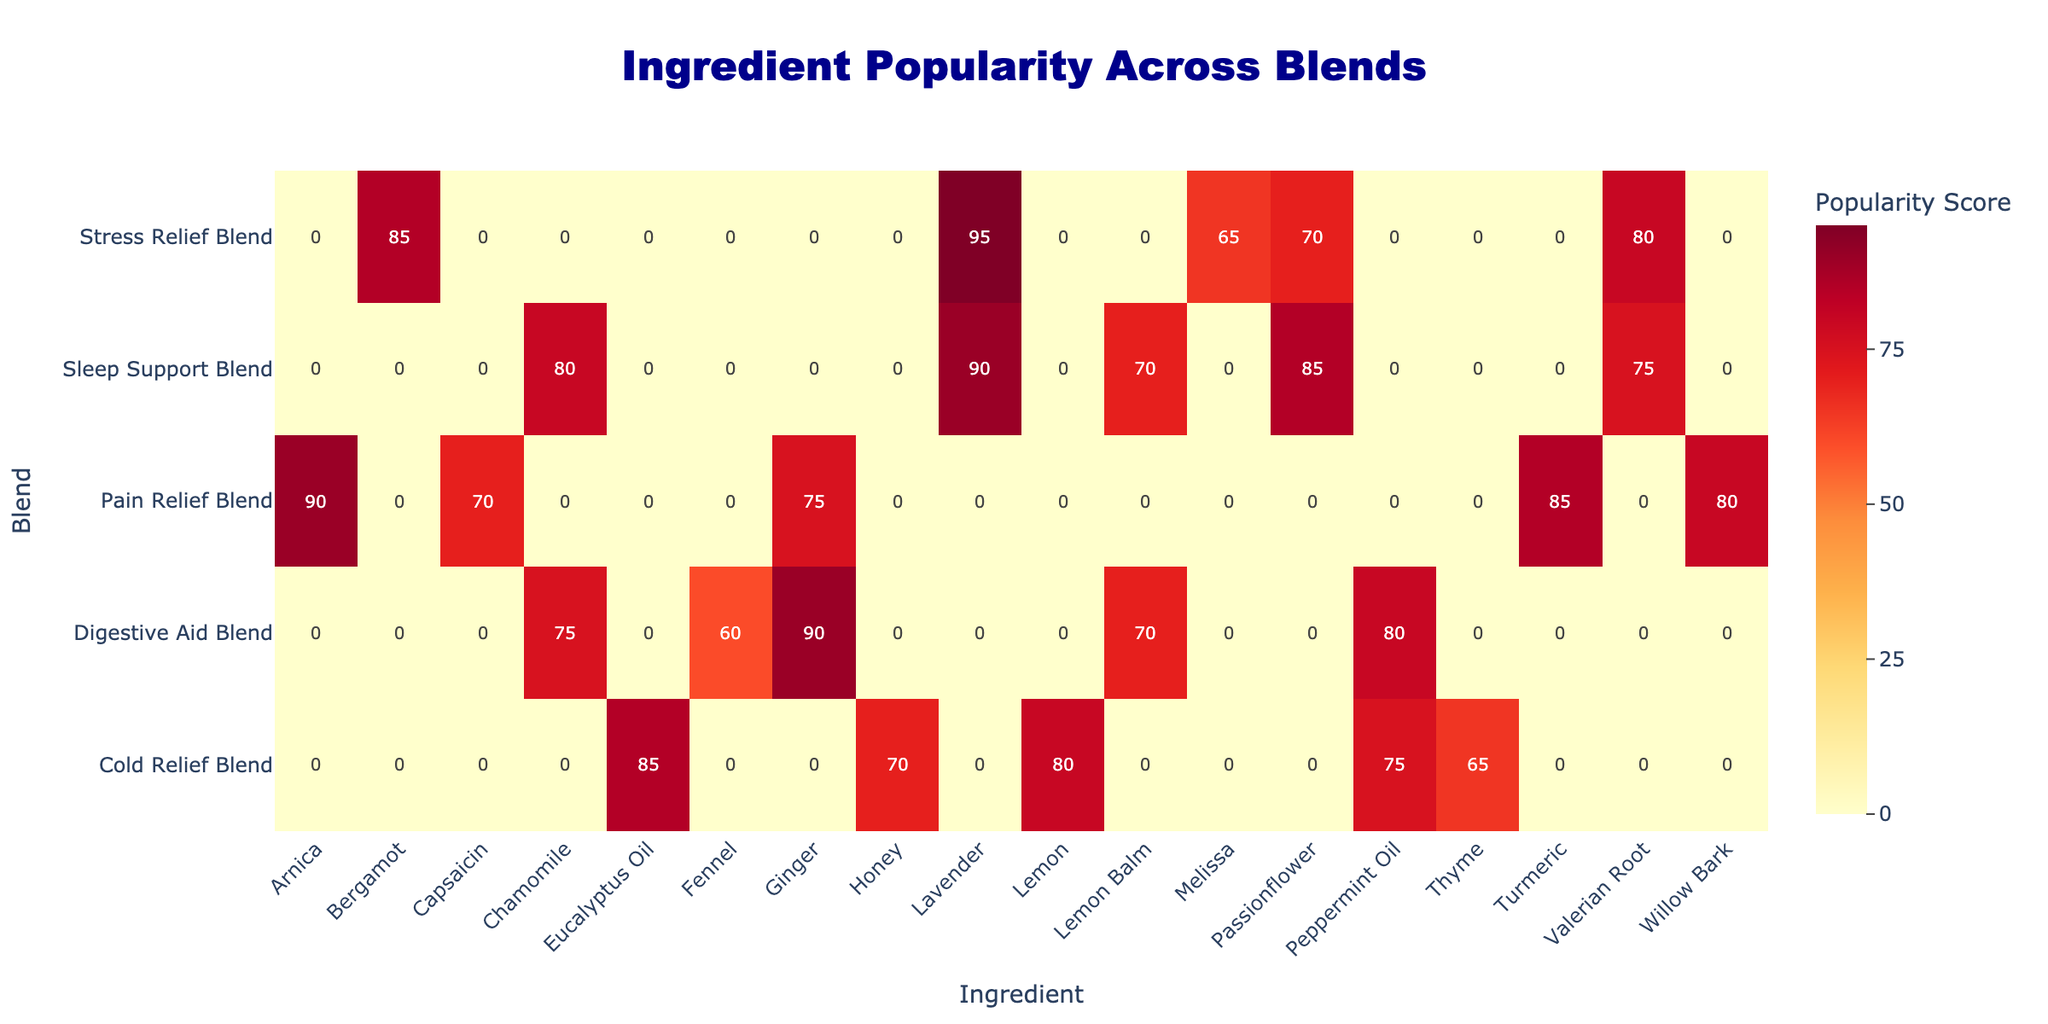What is the highest popularity score among the ingredients in the Cold Relief Blend? The Cold Relief Blend has multiple ingredients, and by checking their popularity scores, we see Eucalyptus Oil has a score of 85, which is higher than the other ingredients (Peppermint Oil 75, Thyme 65, Honey 70, Lemon 80). Therefore, Eucalyptus Oil has the highest score.
Answer: 85 Which ingredient appears in both the Digestive Aid Blend and the Pain Relief Blend? By examining the ingredients listed for each blend, Peppermint Oil is present in both the Digestive Aid Blend (with a score of 80) and does not appear in the Pain Relief Blend. However, Ginger is part of the Digestive Aid Blend (90) but also appears in the Pain Relief Blend (75). Thus, Ginger satisfies the condition.
Answer: Ginger What is the overall average popularity score for Lavender across all blends? Lavender appears in two blends: Stress Relief Blend (95) and Sleep Support Blend (90). To find the average, we add these scores: 95 + 90 = 185, and divide by the number of appearances (2). Hence, the average is 185/2 = 92.5.
Answer: 92.5 Is there any ingredient with a popularity score of 70 in the Sleep Support Blend? Looking at the Sleep Support Blend, the popularity scores for each ingredient are Chamomile (80), Lavender (90), Valerian Root (75), Passionflower (85), and Lemon Balm (70). Since Lemon Balm has a score of exactly 70, the answer is yes.
Answer: Yes What is the total popularity score of all ingredients in the Pain Relief Blend? The ingredients in the Pain Relief Blend and their scores are: Arnica (90), Turmeric (85), Ginger (75), Willow Bark (80), and Capsaicin (70). Adding these scores gives 90 + 85 + 75 + 80 + 70 = 400, which is the total.
Answer: 400 Which blend has the lowest ingredient popularity score overall? To determine this, I will review all the blends and their scores. The lowest score found is for Fennel (60) in the Digestive Aid Blend. Therefore, Digestive Aid Blend contains the ingredient with the lowest score.
Answer: Digestive Aid Blend How many ingredients in the Stress Relief Blend have a popularity score higher than 80? In the Stress Relief Blend, the ingredients are Lavender (95), Bergamot (85), Valerian Root (80), Passionflower (70), and Melissa (65). The scores higher than 80 are from Lavender and Bergamot, giving us 2 ingredients that satisfy the condition.
Answer: 2 What is the difference in popularity scores between Chamomile in the Digestive Aid Blend and the Sleep Support Blend? Chamomile scores 75 in the Digestive Aid Blend and 80 in the Sleep Support Blend. To find the difference, I subtract: 80 - 75 = 5. This indicates that Chamomile has a higher score in the Sleep Support Blend by exactly 5 points.
Answer: 5 Do any blends exclusively use ingredients with a popularity score above 70? Analyzing the blends shows that the Cold Relief Blend's ingredients are: Eucalyptus Oil (85), Peppermint Oil (75), Thyme (65), Honey (70) and Lemon (80). One ingredient (Thyme) has a score below 70. Therefore, not all blends have ingredients above 70, so the answer is no.
Answer: No 